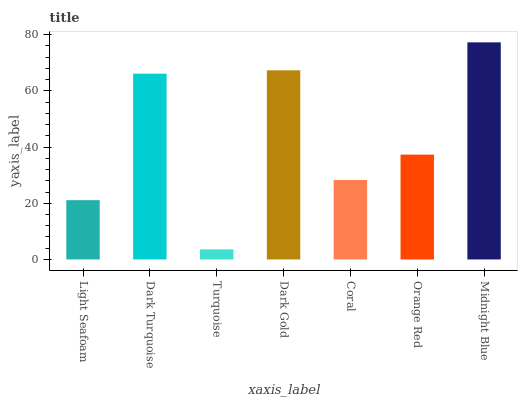Is Turquoise the minimum?
Answer yes or no. Yes. Is Midnight Blue the maximum?
Answer yes or no. Yes. Is Dark Turquoise the minimum?
Answer yes or no. No. Is Dark Turquoise the maximum?
Answer yes or no. No. Is Dark Turquoise greater than Light Seafoam?
Answer yes or no. Yes. Is Light Seafoam less than Dark Turquoise?
Answer yes or no. Yes. Is Light Seafoam greater than Dark Turquoise?
Answer yes or no. No. Is Dark Turquoise less than Light Seafoam?
Answer yes or no. No. Is Orange Red the high median?
Answer yes or no. Yes. Is Orange Red the low median?
Answer yes or no. Yes. Is Midnight Blue the high median?
Answer yes or no. No. Is Coral the low median?
Answer yes or no. No. 